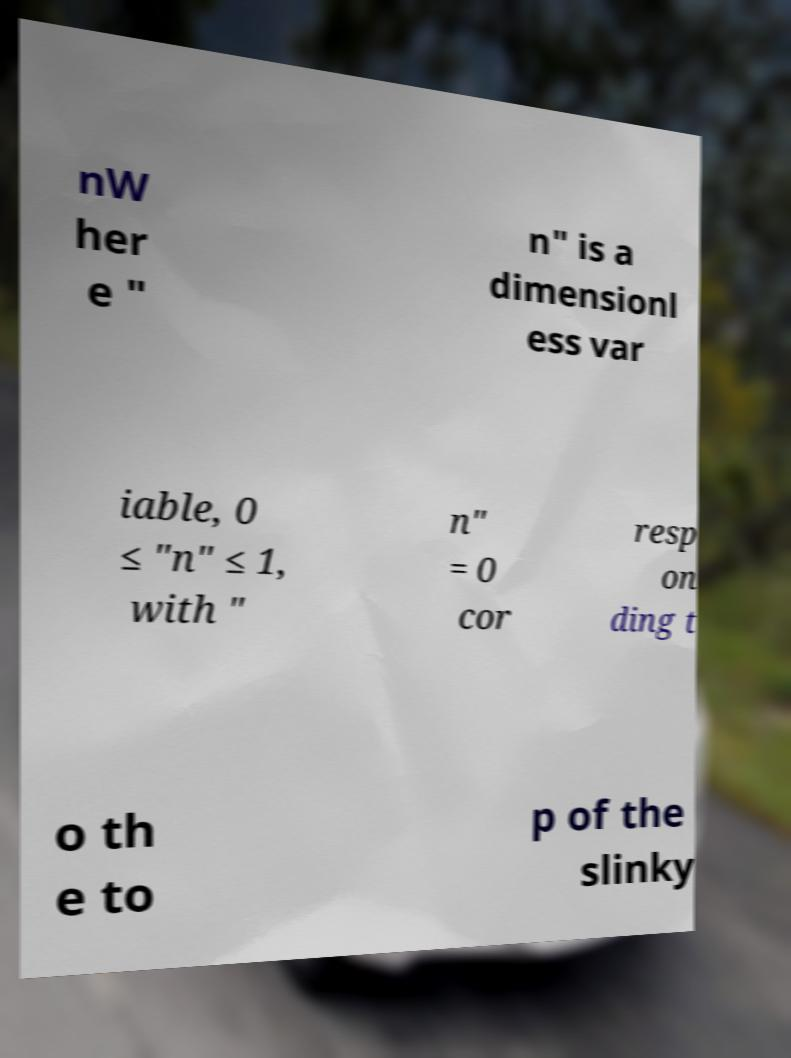What messages or text are displayed in this image? I need them in a readable, typed format. nW her e " n" is a dimensionl ess var iable, 0 ≤ "n" ≤ 1, with " n" = 0 cor resp on ding t o th e to p of the slinky 